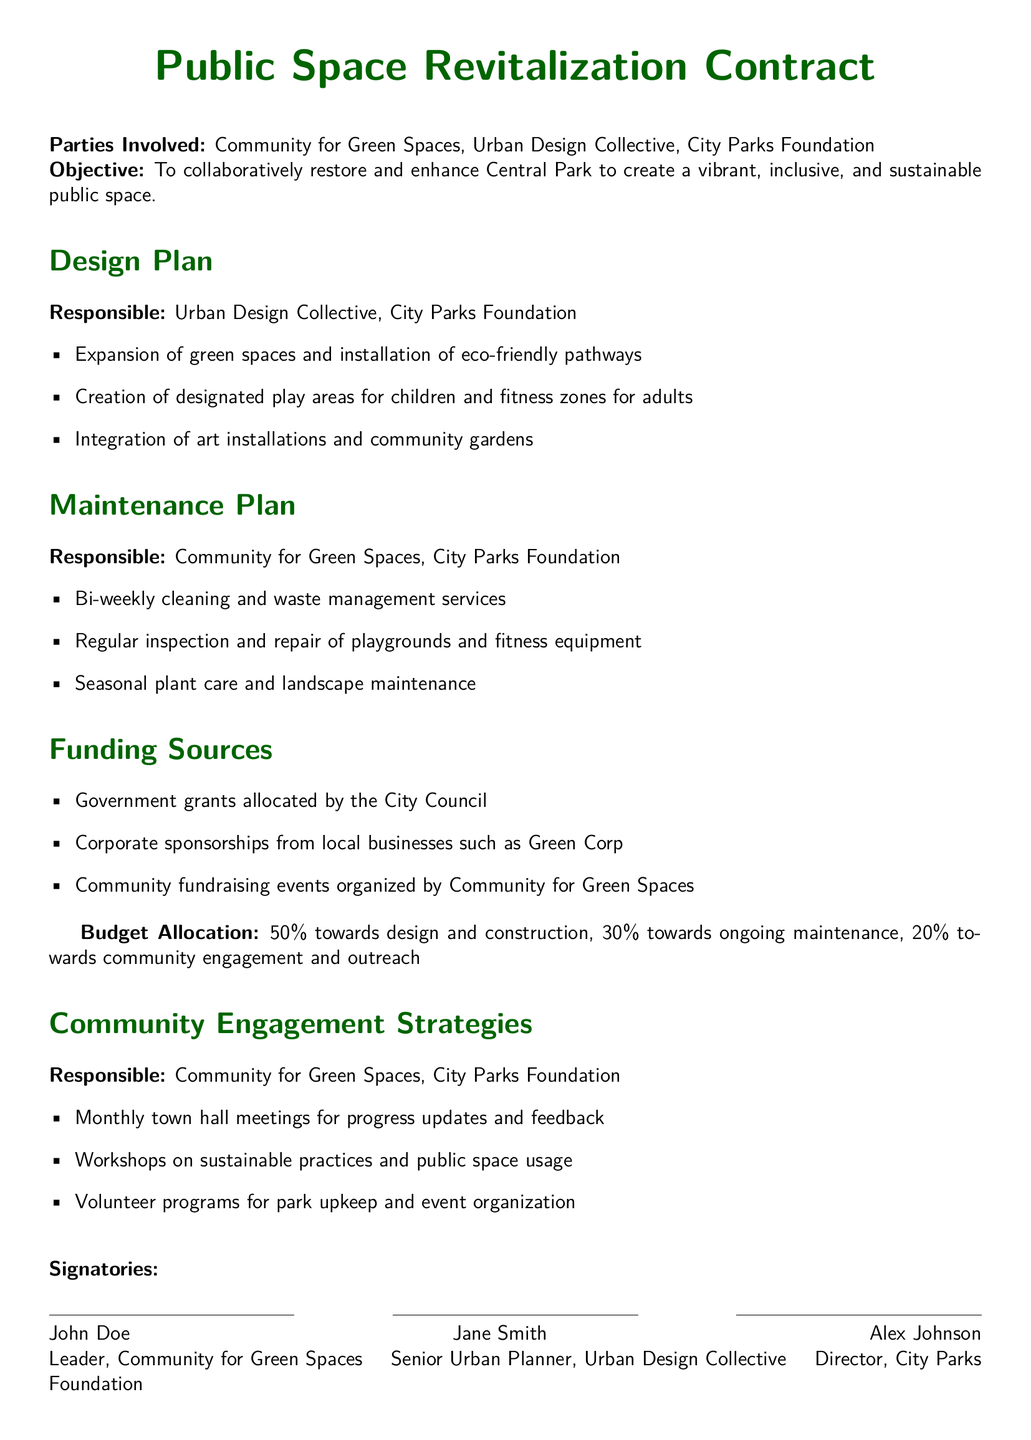What is the main objective of the contract? The objective is clearly stated in the document to collaboratively restore and enhance Central Park.
Answer: To collaboratively restore and enhance Central Park Who is responsible for the design plan? The document lists the Urban Design Collective and City Parks Foundation as responsible parties for the design plan.
Answer: Urban Design Collective, City Parks Foundation What percentage of the budget is allocated to community engagement? The budget allocation states that 20% is specifically set aside for community engagement and outreach.
Answer: 20% What types of strategies are included for community engagement? The document outlines several strategies such as monthly town hall meetings and workshops on sustainable practices.
Answer: Monthly town hall meetings, workshops on sustainable practices How often will maintenance services be conducted? The maintenance plan specifies that cleaning and waste management services will occur bi-weekly.
Answer: Bi-weekly What is one source of funding mentioned in the document? The document includes multiple funding sources, and one of them is government grants allocated by the City Council.
Answer: Government grants allocated by the City Council Who are the signatories of the contract? The signatories section lists three individuals and their roles within their respective organizations.
Answer: John Doe, Jane Smith, Alex Johnson What type of community activities are suggested in the engagement strategies? The strategies include volunteer programs for park upkeep and event organization, indicating active community participation.
Answer: Volunteer programs for park upkeep and event organization 